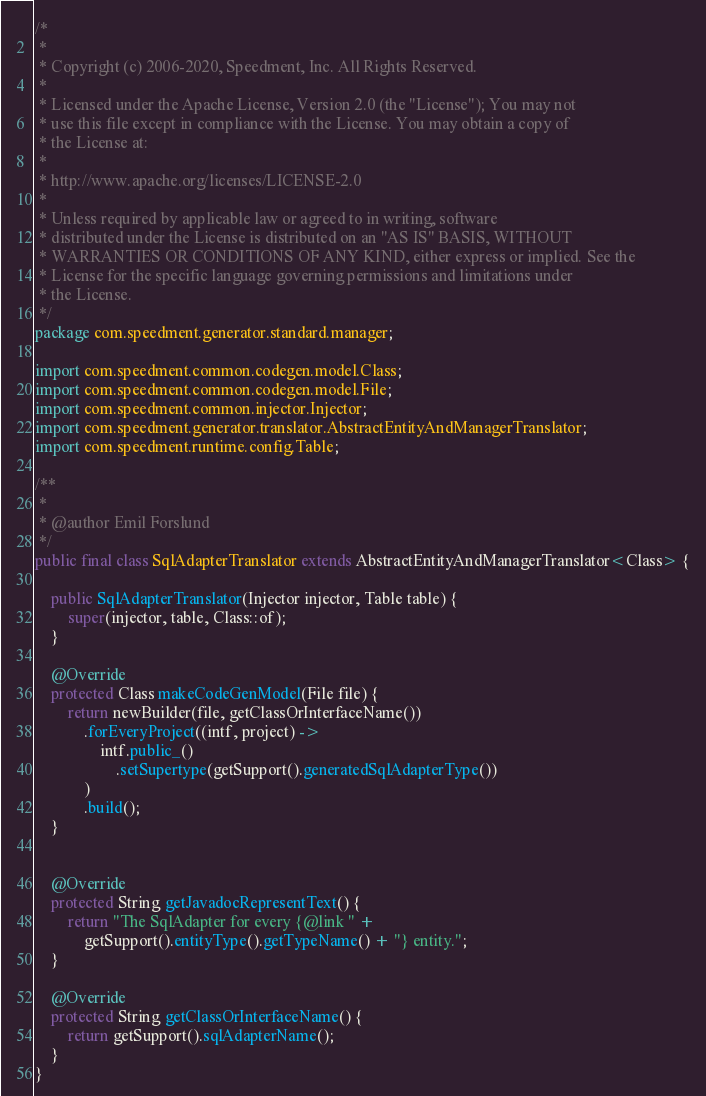Convert code to text. <code><loc_0><loc_0><loc_500><loc_500><_Java_>/*
 *
 * Copyright (c) 2006-2020, Speedment, Inc. All Rights Reserved.
 *
 * Licensed under the Apache License, Version 2.0 (the "License"); You may not
 * use this file except in compliance with the License. You may obtain a copy of
 * the License at:
 *
 * http://www.apache.org/licenses/LICENSE-2.0
 *
 * Unless required by applicable law or agreed to in writing, software
 * distributed under the License is distributed on an "AS IS" BASIS, WITHOUT
 * WARRANTIES OR CONDITIONS OF ANY KIND, either express or implied. See the
 * License for the specific language governing permissions and limitations under
 * the License.
 */
package com.speedment.generator.standard.manager;

import com.speedment.common.codegen.model.Class;
import com.speedment.common.codegen.model.File;
import com.speedment.common.injector.Injector;
import com.speedment.generator.translator.AbstractEntityAndManagerTranslator;
import com.speedment.runtime.config.Table;

/**
 *
 * @author Emil Forslund
 */
public final class SqlAdapterTranslator extends AbstractEntityAndManagerTranslator<Class> {

    public SqlAdapterTranslator(Injector injector, Table table) {
        super(injector, table, Class::of);
    }

    @Override
    protected Class makeCodeGenModel(File file) {
        return newBuilder(file, getClassOrInterfaceName())
            .forEveryProject((intf, project) ->
                intf.public_()
                    .setSupertype(getSupport().generatedSqlAdapterType())
            )
            .build();
    }


    @Override
    protected String getJavadocRepresentText() {
        return "The SqlAdapter for every {@link " + 
            getSupport().entityType().getTypeName() + "} entity.";
    }

    @Override
    protected String getClassOrInterfaceName() {
        return getSupport().sqlAdapterName();
    }
}</code> 